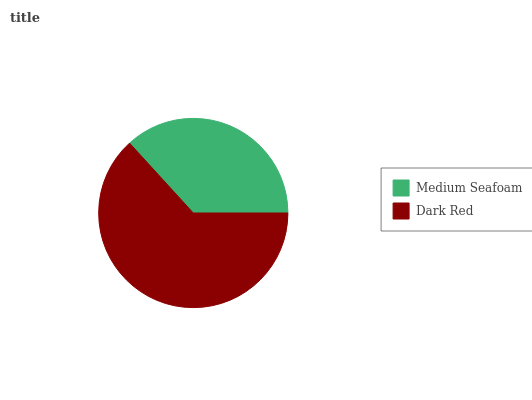Is Medium Seafoam the minimum?
Answer yes or no. Yes. Is Dark Red the maximum?
Answer yes or no. Yes. Is Dark Red the minimum?
Answer yes or no. No. Is Dark Red greater than Medium Seafoam?
Answer yes or no. Yes. Is Medium Seafoam less than Dark Red?
Answer yes or no. Yes. Is Medium Seafoam greater than Dark Red?
Answer yes or no. No. Is Dark Red less than Medium Seafoam?
Answer yes or no. No. Is Dark Red the high median?
Answer yes or no. Yes. Is Medium Seafoam the low median?
Answer yes or no. Yes. Is Medium Seafoam the high median?
Answer yes or no. No. Is Dark Red the low median?
Answer yes or no. No. 